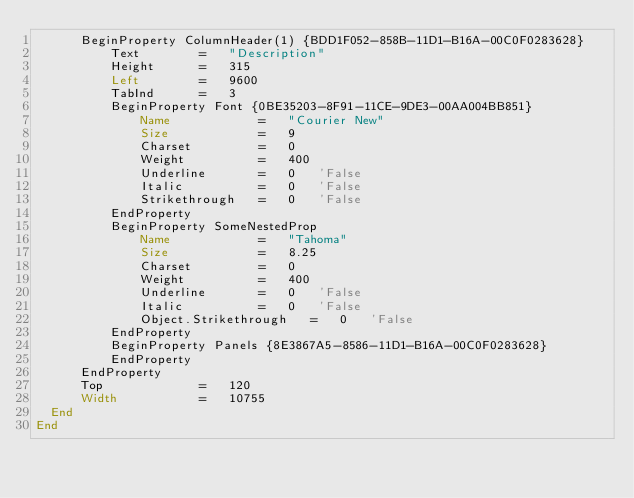<code> <loc_0><loc_0><loc_500><loc_500><_VisualBasic_>      BeginProperty ColumnHeader(1) {BDD1F052-858B-11D1-B16A-00C0F0283628}
          Text        =   "Description"
          Height      =   315
          Left        =   9600
          TabInd      =   3
          BeginProperty Font {0BE35203-8F91-11CE-9DE3-00AA004BB851} 
              Name            =   "Courier New"
              Size            =   9
              Charset         =   0
              Weight          =   400
              Underline       =   0   'False
              Italic          =   0   'False
              Strikethrough   =   0   'False
          EndProperty
          BeginProperty SomeNestedProp 
              Name            =   "Tahoma"
              Size            =   8.25
              Charset         =   0
              Weight          =   400
              Underline       =   0   'False
              Italic          =   0   'False
              Object.Strikethrough   =   0   'False
          EndProperty
          BeginProperty Panels {8E3867A5-8586-11D1-B16A-00C0F0283628} 
          EndProperty
      EndProperty
      Top             =   120
      Width           =   10755
  End
End</code> 